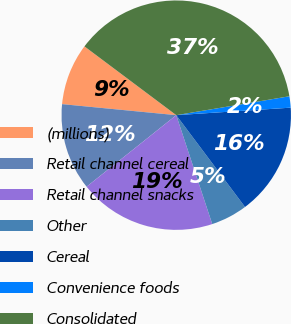Convert chart. <chart><loc_0><loc_0><loc_500><loc_500><pie_chart><fcel>(millions)<fcel>Retail channel cereal<fcel>Retail channel snacks<fcel>Other<fcel>Cereal<fcel>Convenience foods<fcel>Consolidated<nl><fcel>8.7%<fcel>12.25%<fcel>19.36%<fcel>5.15%<fcel>15.81%<fcel>1.59%<fcel>37.13%<nl></chart> 